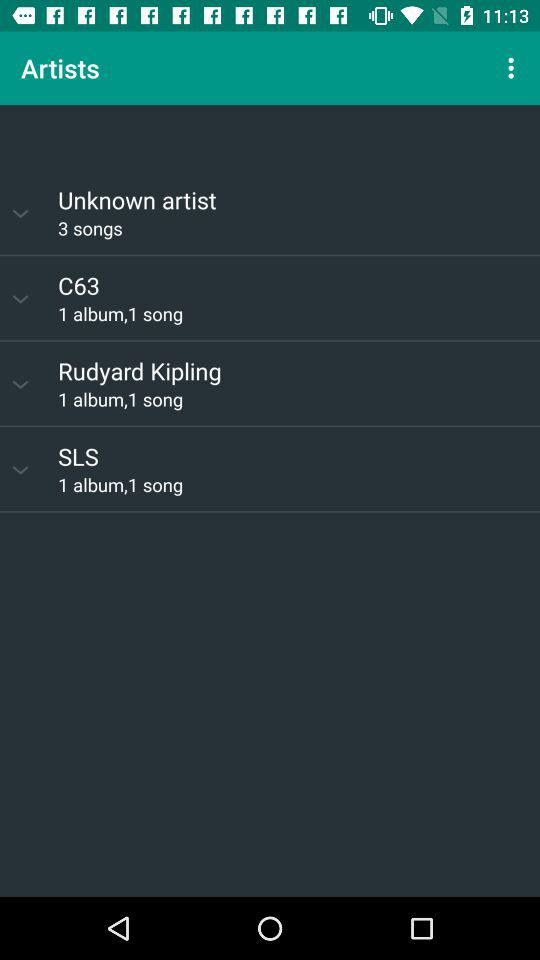How many songs are there by unknown artist?
Answer the question using a single word or phrase. 3 